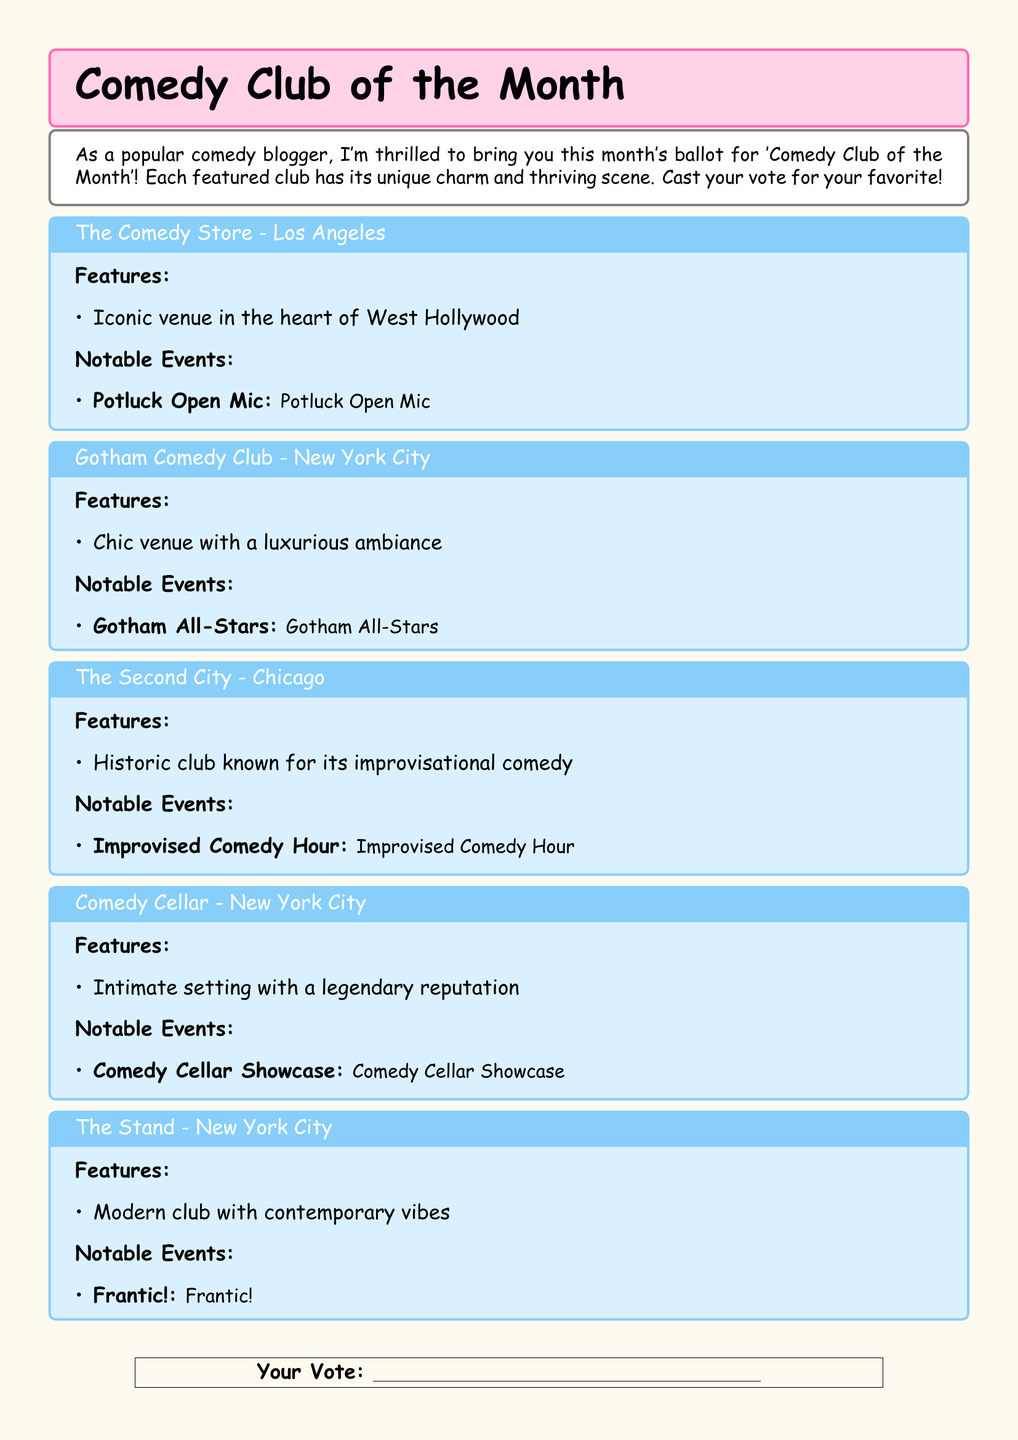What is the location of The Comedy Store? The Comedy Store is located in West Hollywood, Los Angeles, which is mentioned in its description.
Answer: Los Angeles What notable event does Gotham Comedy Club host? The notable event hosted by Gotham Comedy Club is listed as Gotham All-Stars.
Answer: Gotham All-Stars What type of comedy is The Second City known for? The Second City is noted for its improvisational comedy in the document.
Answer: Improvisational comedy Which club features an intimate setting? Comedy Cellar is described as having an intimate setting with a legendary reputation.
Answer: Comedy Cellar What color is the background of the ballot? The background color of the ballot is specified in the document as ballotbg, which is a light color.
Answer: Light color Which city is home to The Stand? The club named The Stand is located in New York City, as indicated.
Answer: New York City What is the unique feature of The Comedy Store? The unique feature of The Comedy Store mentioned is its iconic venue in the heart of West Hollywood.
Answer: Iconic venue How many clubs are listed in the document? The document lists five different clubs for the ballot.
Answer: Five What is the theme of the document? The theme of the document revolves around voting for the 'Comedy Club of the Month.’
Answer: Comedy Club of the Month 